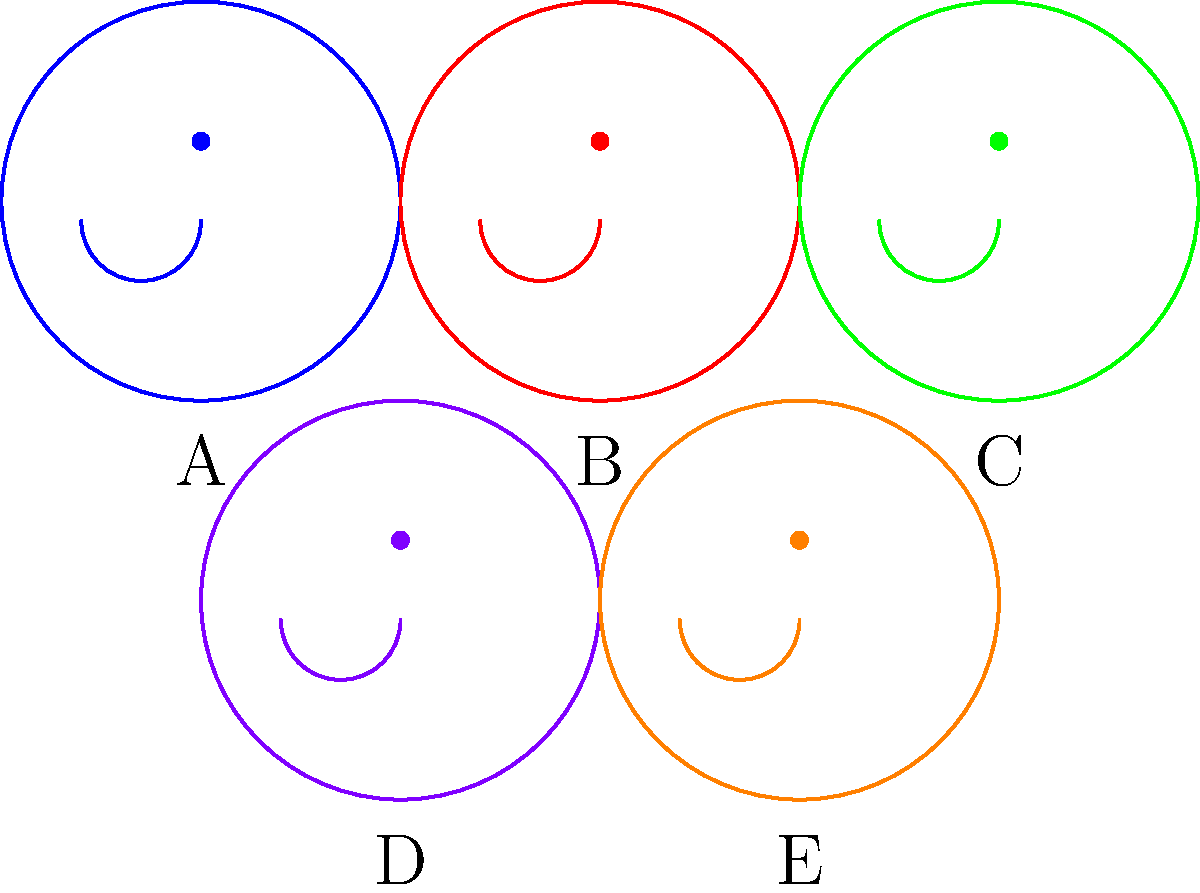In this lineup of celebrity photos, which image is most likely to be manipulated based on subtle inconsistencies that could be exploited for publicity or political gain? To identify the manipulated photo, we need to analyze each image for signs of alteration:

1. Image A (Blue): Appears standard with no obvious signs of manipulation.
2. Image B (Red): The facial features seem disproportionate, suggesting possible alteration.
3. Image C (Green): Looks natural with no clear indications of manipulation.
4. Image D (Purple): The symmetry appears too perfect, which is often a sign of digital enhancement.
5. Image E (Orange): Shows no apparent signs of manipulation.

Given your background in showbiz and understanding of publicity tactics, you'd likely focus on Image D. The unnaturally perfect symmetry is a common tell-tale sign of digital manipulation, often used to enhance a celebrity's appearance for maximum impact in media or political campaigns. This level of perfection is rarely found in unaltered photos and could be exploited for various publicity or political purposes.
Answer: Image D (Purple) 